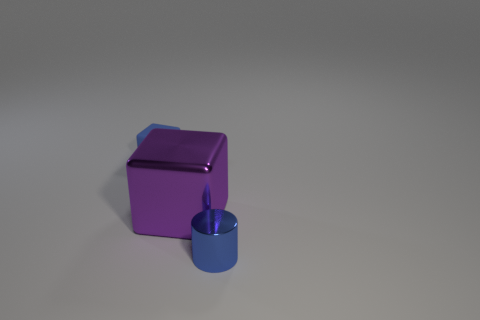Add 1 tiny blue things. How many objects exist? 4 Subtract all cylinders. How many objects are left? 2 Subtract 0 yellow spheres. How many objects are left? 3 Subtract all large gray metal objects. Subtract all purple shiny cubes. How many objects are left? 2 Add 2 small blue metallic objects. How many small blue metallic objects are left? 3 Add 1 large red metallic spheres. How many large red metallic spheres exist? 1 